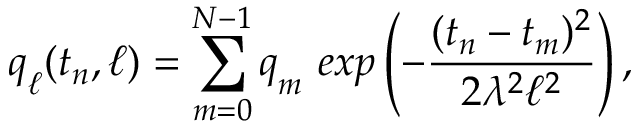<formula> <loc_0><loc_0><loc_500><loc_500>q _ { \ell } ( t _ { n } , \ell ) = \sum _ { m = 0 } ^ { N - 1 } q _ { m } e x p \left ( - \frac { ( t _ { n } - t _ { m } ) ^ { 2 } } { 2 \lambda ^ { 2 } \ell ^ { 2 } } \right ) ,</formula> 